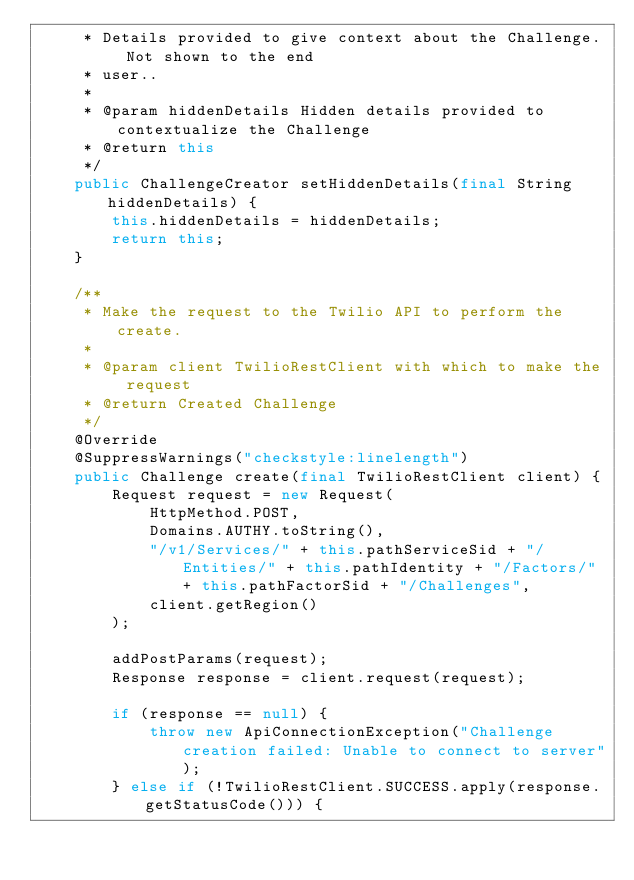Convert code to text. <code><loc_0><loc_0><loc_500><loc_500><_Java_>     * Details provided to give context about the Challenge. Not shown to the end
     * user..
     *
     * @param hiddenDetails Hidden details provided to contextualize the Challenge
     * @return this
     */
    public ChallengeCreator setHiddenDetails(final String hiddenDetails) {
        this.hiddenDetails = hiddenDetails;
        return this;
    }

    /**
     * Make the request to the Twilio API to perform the create.
     *
     * @param client TwilioRestClient with which to make the request
     * @return Created Challenge
     */
    @Override
    @SuppressWarnings("checkstyle:linelength")
    public Challenge create(final TwilioRestClient client) {
        Request request = new Request(
            HttpMethod.POST,
            Domains.AUTHY.toString(),
            "/v1/Services/" + this.pathServiceSid + "/Entities/" + this.pathIdentity + "/Factors/" + this.pathFactorSid + "/Challenges",
            client.getRegion()
        );

        addPostParams(request);
        Response response = client.request(request);

        if (response == null) {
            throw new ApiConnectionException("Challenge creation failed: Unable to connect to server");
        } else if (!TwilioRestClient.SUCCESS.apply(response.getStatusCode())) {</code> 